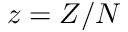<formula> <loc_0><loc_0><loc_500><loc_500>z = Z / N</formula> 